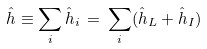Convert formula to latex. <formula><loc_0><loc_0><loc_500><loc_500>\hat { h } \equiv \sum _ { i } \hat { h } _ { i } \, = \, \sum _ { i } ( \hat { h } _ { L } + \hat { h } _ { I } )</formula> 